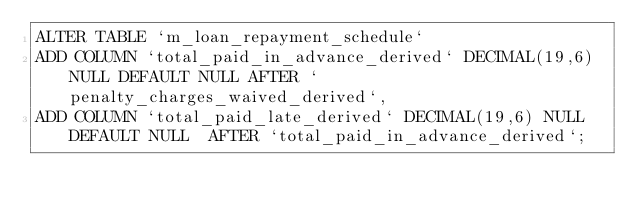Convert code to text. <code><loc_0><loc_0><loc_500><loc_500><_SQL_>ALTER TABLE `m_loan_repayment_schedule`
ADD COLUMN `total_paid_in_advance_derived` DECIMAL(19,6) NULL DEFAULT NULL AFTER `penalty_charges_waived_derived`,
ADD COLUMN `total_paid_late_derived` DECIMAL(19,6) NULL DEFAULT NULL  AFTER `total_paid_in_advance_derived`;</code> 